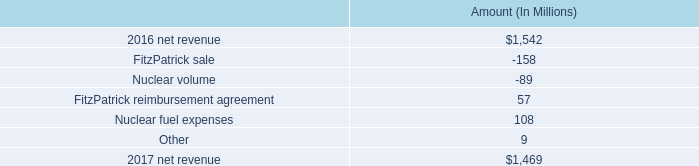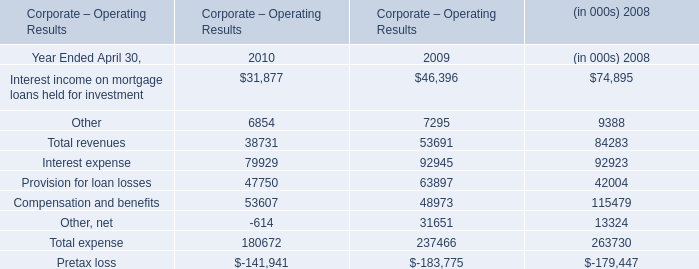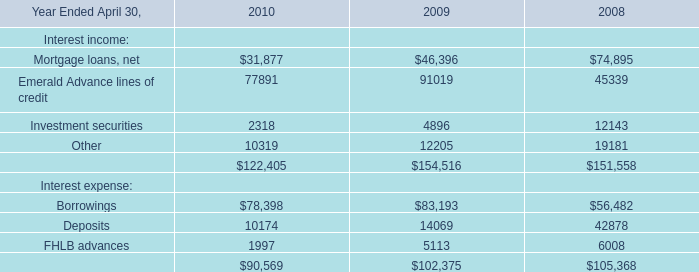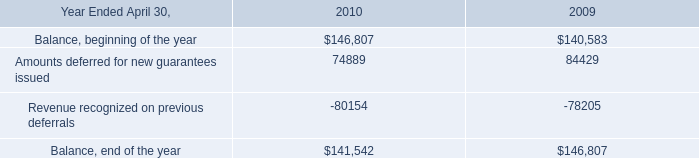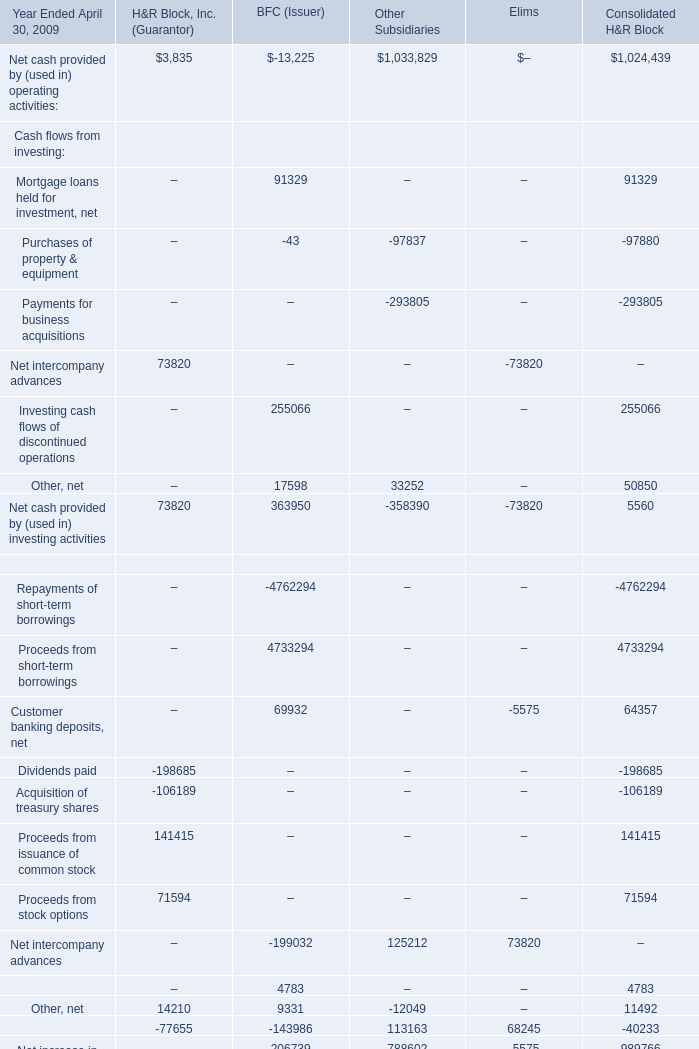what is the percent change in net revenue from 2016 to 2017? 
Computations: ((1542 - 1469) / 1469)
Answer: 0.04969. 